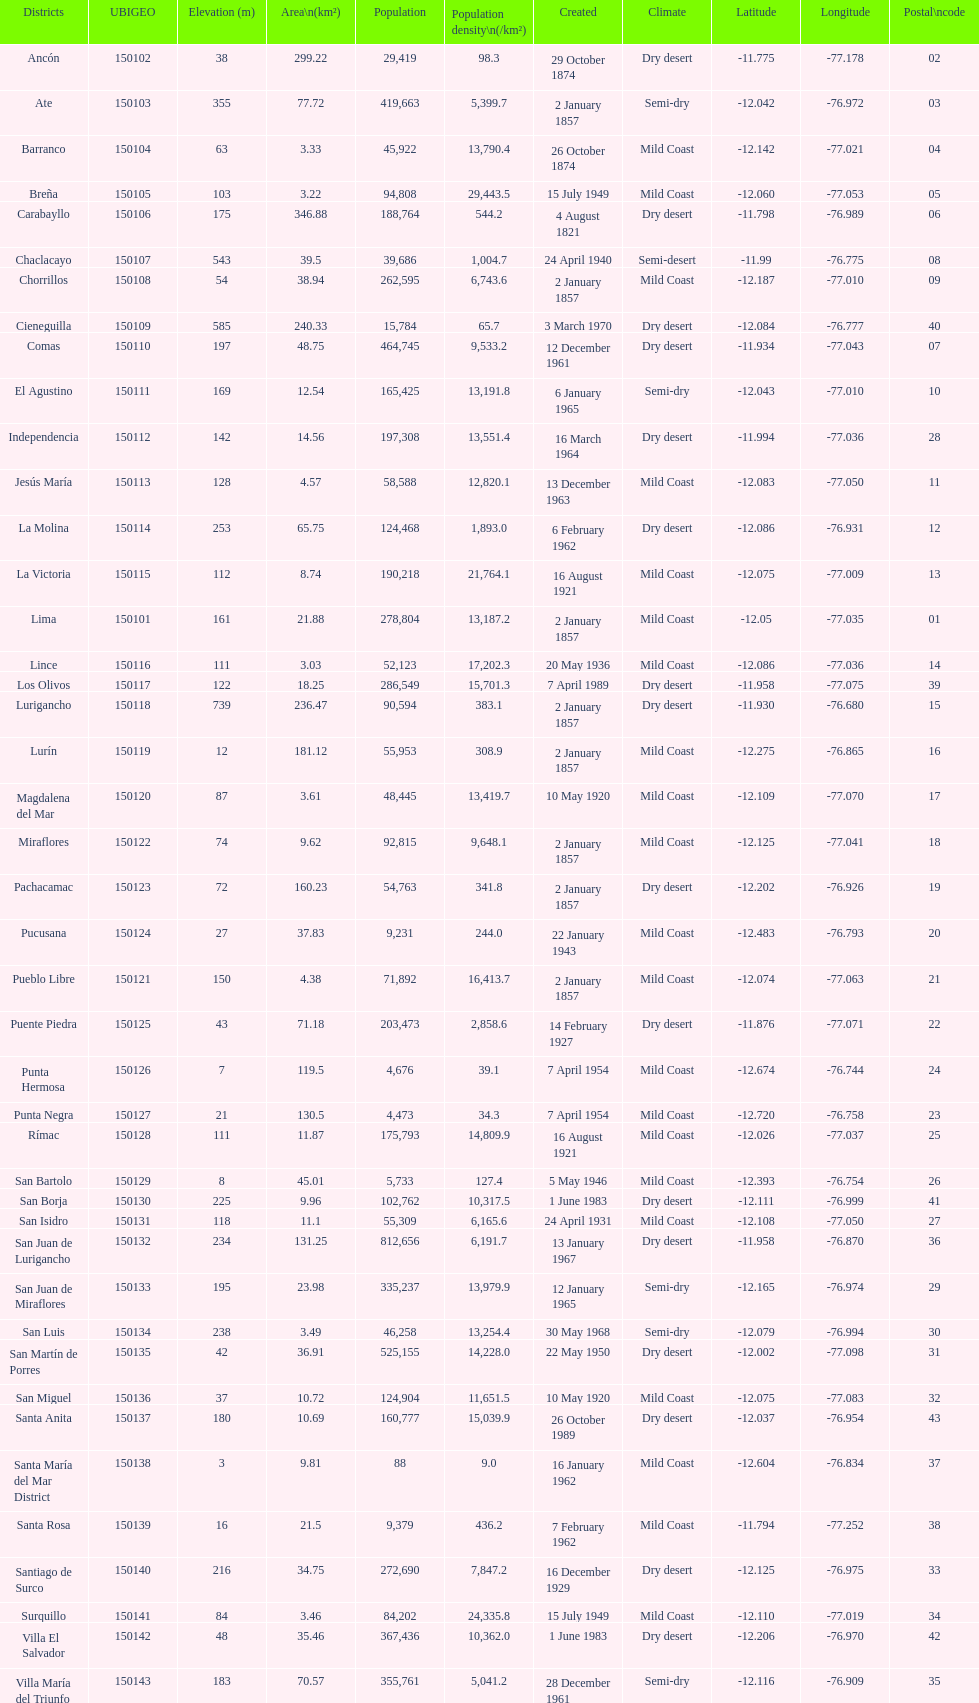What district has the least amount of population? Santa María del Mar District. I'm looking to parse the entire table for insights. Could you assist me with that? {'header': ['Districts', 'UBIGEO', 'Elevation (m)', 'Area\\n(km²)', 'Population', 'Population density\\n(/km²)', 'Created', 'Climate', 'Latitude', 'Longitude', 'Postal\\ncode'], 'rows': [['Ancón', '150102', '38', '299.22', '29,419', '98.3', '29 October 1874', 'Dry desert', '-11.775', '-77.178', '02'], ['Ate', '150103', '355', '77.72', '419,663', '5,399.7', '2 January 1857', 'Semi-dry', '-12.042', '-76.972', '03'], ['Barranco', '150104', '63', '3.33', '45,922', '13,790.4', '26 October 1874', 'Mild Coast', '-12.142', '-77.021', '04'], ['Breña', '150105', '103', '3.22', '94,808', '29,443.5', '15 July 1949', 'Mild Coast', '-12.060', '-77.053', '05'], ['Carabayllo', '150106', '175', '346.88', '188,764', '544.2', '4 August 1821', 'Dry desert', '-11.798', '-76.989', '06'], ['Chaclacayo', '150107', '543', '39.5', '39,686', '1,004.7', '24 April 1940', 'Semi-desert', '-11.99', '-76.775', '08'], ['Chorrillos', '150108', '54', '38.94', '262,595', '6,743.6', '2 January 1857', 'Mild Coast', '-12.187', '-77.010', '09'], ['Cieneguilla', '150109', '585', '240.33', '15,784', '65.7', '3 March 1970', 'Dry desert', '-12.084', '-76.777', '40'], ['Comas', '150110', '197', '48.75', '464,745', '9,533.2', '12 December 1961', 'Dry desert', '-11.934', '-77.043', '07'], ['El Agustino', '150111', '169', '12.54', '165,425', '13,191.8', '6 January 1965', 'Semi-dry', '-12.043', '-77.010', '10'], ['Independencia', '150112', '142', '14.56', '197,308', '13,551.4', '16 March 1964', 'Dry desert', '-11.994', '-77.036', '28'], ['Jesús María', '150113', '128', '4.57', '58,588', '12,820.1', '13 December 1963', 'Mild Coast', '-12.083', '-77.050', '11'], ['La Molina', '150114', '253', '65.75', '124,468', '1,893.0', '6 February 1962', 'Dry desert', '-12.086', '-76.931', '12'], ['La Victoria', '150115', '112', '8.74', '190,218', '21,764.1', '16 August 1921', 'Mild Coast', '-12.075', '-77.009', '13'], ['Lima', '150101', '161', '21.88', '278,804', '13,187.2', '2 January 1857', 'Mild Coast', '-12.05', '-77.035', '01'], ['Lince', '150116', '111', '3.03', '52,123', '17,202.3', '20 May 1936', 'Mild Coast', '-12.086', '-77.036', '14'], ['Los Olivos', '150117', '122', '18.25', '286,549', '15,701.3', '7 April 1989', 'Dry desert', '-11.958', '-77.075', '39'], ['Lurigancho', '150118', '739', '236.47', '90,594', '383.1', '2 January 1857', 'Dry desert', '-11.930', '-76.680', '15'], ['Lurín', '150119', '12', '181.12', '55,953', '308.9', '2 January 1857', 'Mild Coast', '-12.275', '-76.865', '16'], ['Magdalena del Mar', '150120', '87', '3.61', '48,445', '13,419.7', '10 May 1920', 'Mild Coast', '-12.109', '-77.070', '17'], ['Miraflores', '150122', '74', '9.62', '92,815', '9,648.1', '2 January 1857', 'Mild Coast', '-12.125', '-77.041', '18'], ['Pachacamac', '150123', '72', '160.23', '54,763', '341.8', '2 January 1857', 'Dry desert', '-12.202', '-76.926', '19'], ['Pucusana', '150124', '27', '37.83', '9,231', '244.0', '22 January 1943', 'Mild Coast', '-12.483', '-76.793', '20'], ['Pueblo Libre', '150121', '150', '4.38', '71,892', '16,413.7', '2 January 1857', 'Mild Coast', '-12.074', '-77.063', '21'], ['Puente Piedra', '150125', '43', '71.18', '203,473', '2,858.6', '14 February 1927', 'Dry desert', '-11.876', '-77.071', '22'], ['Punta Hermosa', '150126', '7', '119.5', '4,676', '39.1', '7 April 1954', 'Mild Coast', '-12.674', '-76.744', '24'], ['Punta Negra', '150127', '21', '130.5', '4,473', '34.3', '7 April 1954', 'Mild Coast', '-12.720', '-76.758', '23'], ['Rímac', '150128', '111', '11.87', '175,793', '14,809.9', '16 August 1921', 'Mild Coast', '-12.026', '-77.037', '25'], ['San Bartolo', '150129', '8', '45.01', '5,733', '127.4', '5 May 1946', 'Mild Coast', '-12.393', '-76.754', '26'], ['San Borja', '150130', '225', '9.96', '102,762', '10,317.5', '1 June 1983', 'Dry desert', '-12.111', '-76.999', '41'], ['San Isidro', '150131', '118', '11.1', '55,309', '6,165.6', '24 April 1931', 'Mild Coast', '-12.108', '-77.050', '27'], ['San Juan de Lurigancho', '150132', '234', '131.25', '812,656', '6,191.7', '13 January 1967', 'Dry desert', '-11.958', '-76.870', '36'], ['San Juan de Miraflores', '150133', '195', '23.98', '335,237', '13,979.9', '12 January 1965', 'Semi-dry', '-12.165', '-76.974', '29'], ['San Luis', '150134', '238', '3.49', '46,258', '13,254.4', '30 May 1968', 'Semi-dry', '-12.079', '-76.994', '30'], ['San Martín de Porres', '150135', '42', '36.91', '525,155', '14,228.0', '22 May 1950', 'Dry desert', '-12.002', '-77.098', '31'], ['San Miguel', '150136', '37', '10.72', '124,904', '11,651.5', '10 May 1920', 'Mild Coast', '-12.075', '-77.083', '32'], ['Santa Anita', '150137', '180', '10.69', '160,777', '15,039.9', '26 October 1989', 'Dry desert', '-12.037', '-76.954', '43'], ['Santa María del Mar District', '150138', '3', '9.81', '88', '9.0', '16 January 1962', 'Mild Coast', '-12.604', '-76.834', '37'], ['Santa Rosa', '150139', '16', '21.5', '9,379', '436.2', '7 February 1962', 'Mild Coast', '-11.794', '-77.252', '38'], ['Santiago de Surco', '150140', '216', '34.75', '272,690', '7,847.2', '16 December 1929', 'Dry desert', '-12.125', '-76.975', '33'], ['Surquillo', '150141', '84', '3.46', '84,202', '24,335.8', '15 July 1949', 'Mild Coast', '-12.110', '-77.019', '34'], ['Villa El Salvador', '150142', '48', '35.46', '367,436', '10,362.0', '1 June 1983', 'Dry desert', '-12.206', '-76.970', '42'], ['Villa María del Triunfo', '150143', '183', '70.57', '355,761', '5,041.2', '28 December 1961', 'Semi-dry', '-12.116', '-76.909', '35']]} 